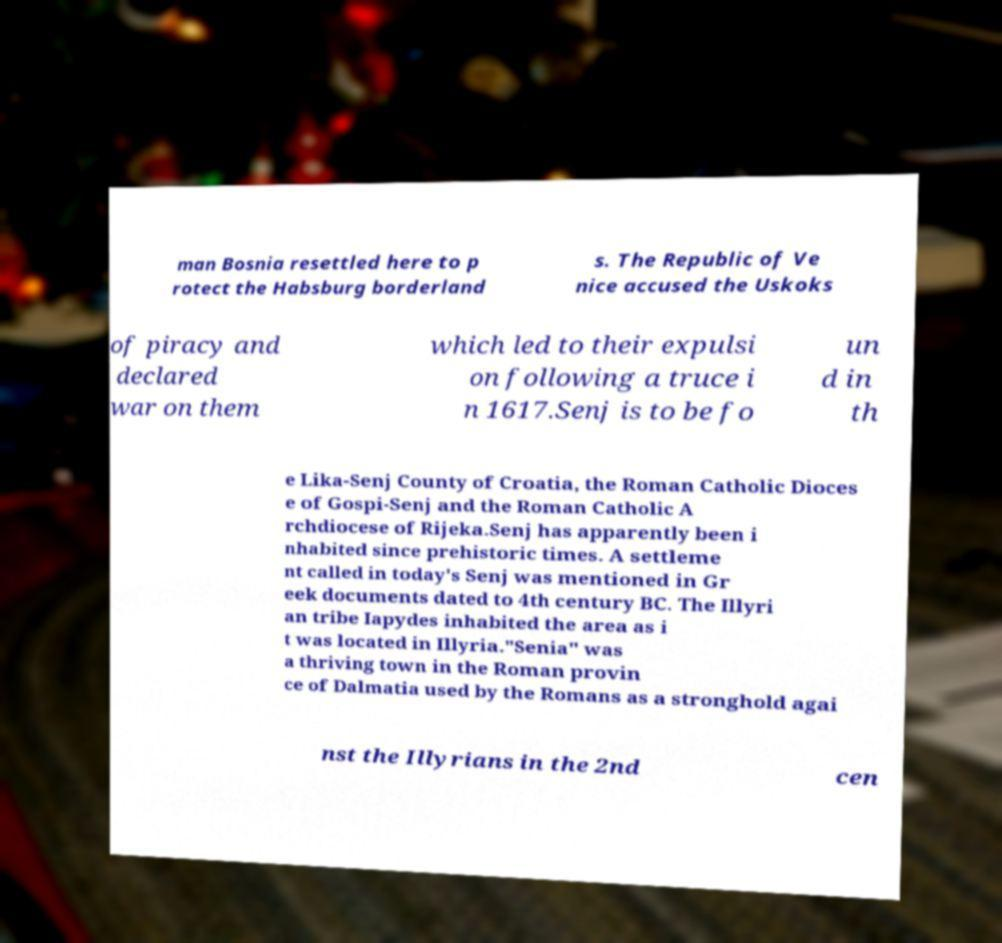What messages or text are displayed in this image? I need them in a readable, typed format. man Bosnia resettled here to p rotect the Habsburg borderland s. The Republic of Ve nice accused the Uskoks of piracy and declared war on them which led to their expulsi on following a truce i n 1617.Senj is to be fo un d in th e Lika-Senj County of Croatia, the Roman Catholic Dioces e of Gospi-Senj and the Roman Catholic A rchdiocese of Rijeka.Senj has apparently been i nhabited since prehistoric times. A settleme nt called in today's Senj was mentioned in Gr eek documents dated to 4th century BC. The Illyri an tribe Iapydes inhabited the area as i t was located in Illyria."Senia" was a thriving town in the Roman provin ce of Dalmatia used by the Romans as a stronghold agai nst the Illyrians in the 2nd cen 